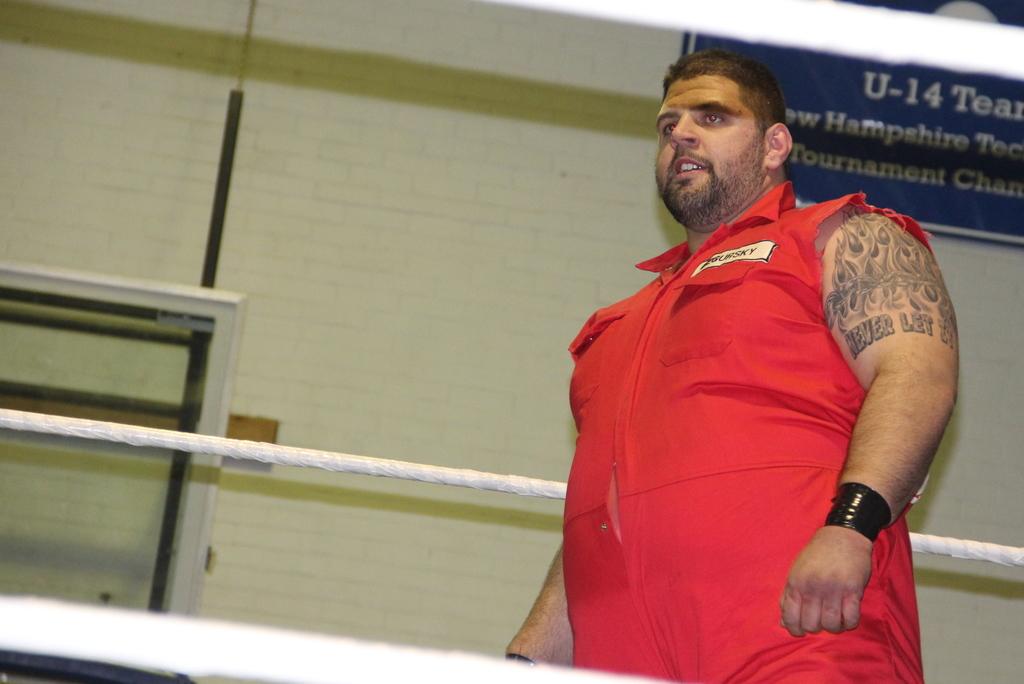What state name can be seen on the sign behind the man?
Provide a short and direct response. New hampshire. 